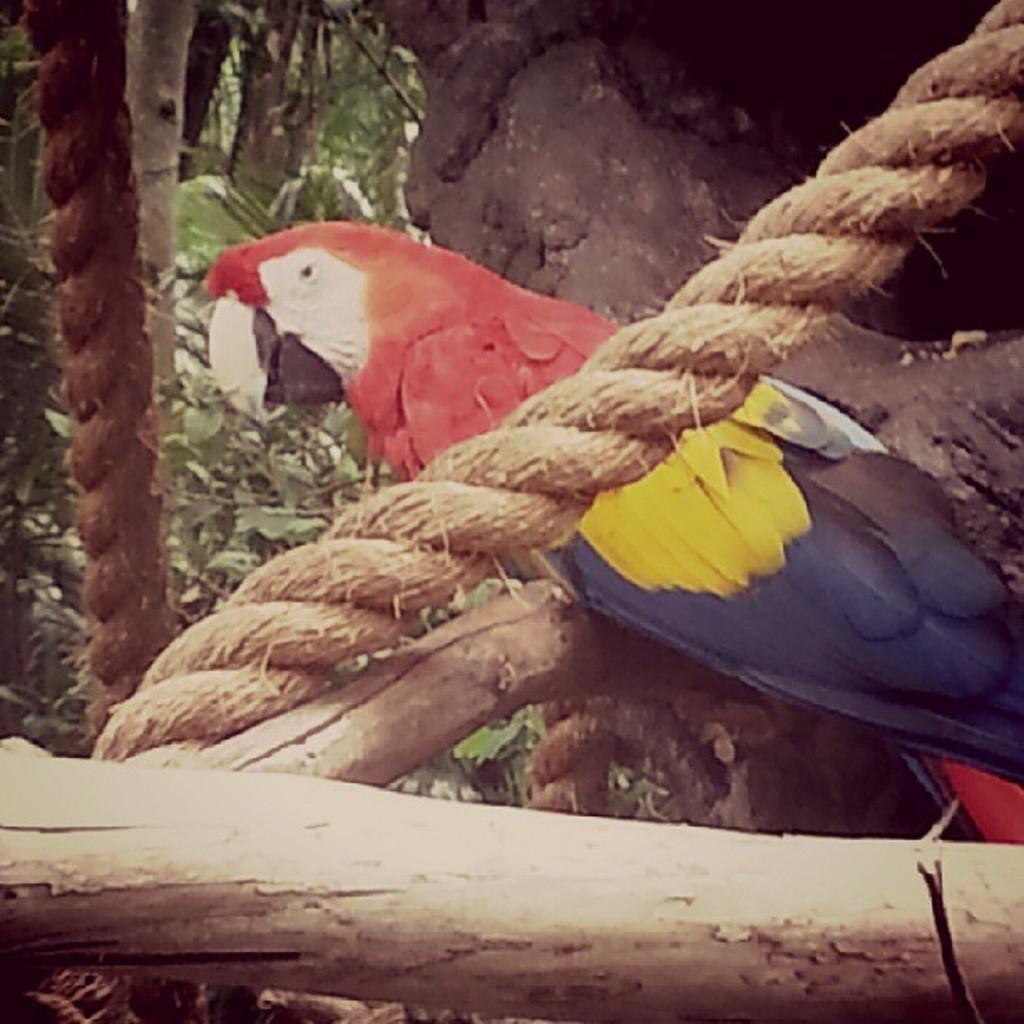Please provide a concise description of this image. In this image, we can see a parrot, ropes and wooden objects. Background we can see few trees. 